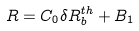Convert formula to latex. <formula><loc_0><loc_0><loc_500><loc_500>R = C _ { 0 } \delta R _ { b } ^ { t h } + B _ { 1 }</formula> 